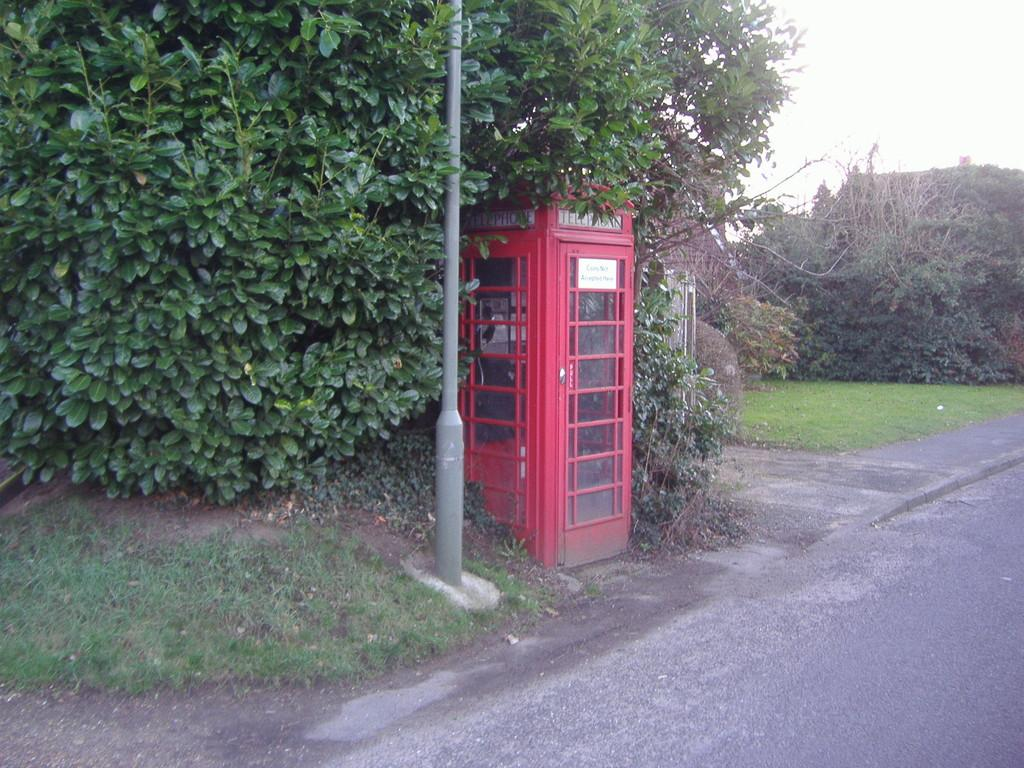What is the main subject in the center of the image? There is a telephone box in the center of the image. How is the telephone box positioned in the image? The telephone box is placed on the ground. What else can be seen in the image besides the telephone box? There is a pole in the image. What can be seen in the background of the image? There is a group of trees and the sky visible in the background of the image. What type of crack can be seen on the telephone box in the image? There is no crack visible on the telephone box in the image. What experience does the person using the telephone box have in the image? There is no person using the telephone box in the image, so it is impossible to determine their experience. 